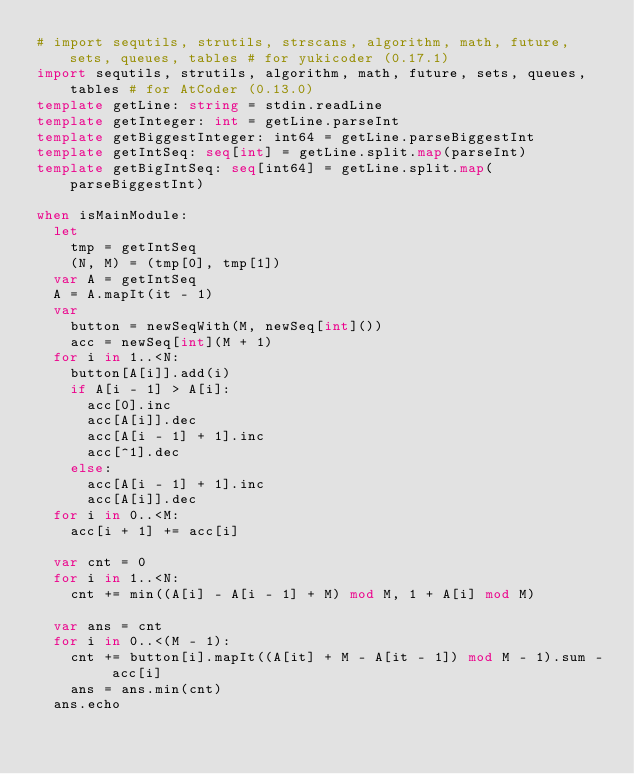<code> <loc_0><loc_0><loc_500><loc_500><_Nim_># import sequtils, strutils, strscans, algorithm, math, future, sets, queues, tables # for yukicoder (0.17.1)
import sequtils, strutils, algorithm, math, future, sets, queues, tables # for AtCoder (0.13.0)
template getLine: string = stdin.readLine
template getInteger: int = getLine.parseInt
template getBiggestInteger: int64 = getLine.parseBiggestInt
template getIntSeq: seq[int] = getLine.split.map(parseInt)
template getBigIntSeq: seq[int64] = getLine.split.map(parseBiggestInt)

when isMainModule:
  let
    tmp = getIntSeq
    (N, M) = (tmp[0], tmp[1])
  var A = getIntSeq
  A = A.mapIt(it - 1)
  var
    button = newSeqWith(M, newSeq[int]())
    acc = newSeq[int](M + 1)
  for i in 1..<N:
    button[A[i]].add(i)
    if A[i - 1] > A[i]:
      acc[0].inc
      acc[A[i]].dec
      acc[A[i - 1] + 1].inc
      acc[^1].dec
    else:
      acc[A[i - 1] + 1].inc
      acc[A[i]].dec
  for i in 0..<M:
    acc[i + 1] += acc[i]

  var cnt = 0
  for i in 1..<N:
    cnt += min((A[i] - A[i - 1] + M) mod M, 1 + A[i] mod M)

  var ans = cnt
  for i in 0..<(M - 1):
    cnt += button[i].mapIt((A[it] + M - A[it - 1]) mod M - 1).sum - acc[i]
    ans = ans.min(cnt)
  ans.echo
</code> 